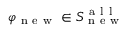<formula> <loc_0><loc_0><loc_500><loc_500>\varphi _ { n e w } \in S _ { n e w } ^ { a l l }</formula> 